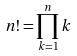<formula> <loc_0><loc_0><loc_500><loc_500>n ! = \prod _ { k = 1 } ^ { n } k</formula> 